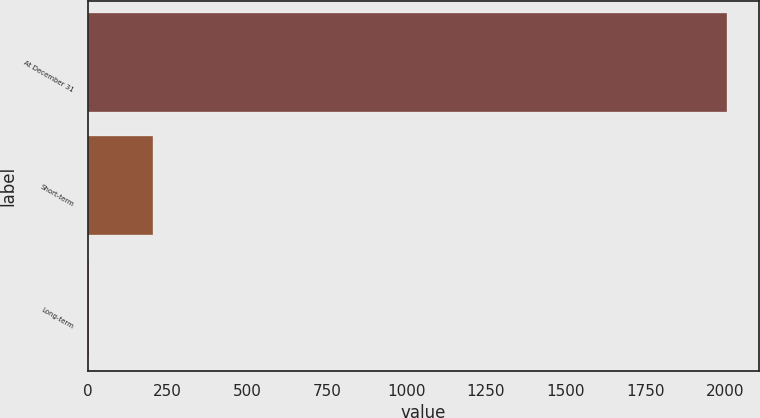<chart> <loc_0><loc_0><loc_500><loc_500><bar_chart><fcel>At December 31<fcel>Short-term<fcel>Long-term<nl><fcel>2006<fcel>203.74<fcel>3.49<nl></chart> 